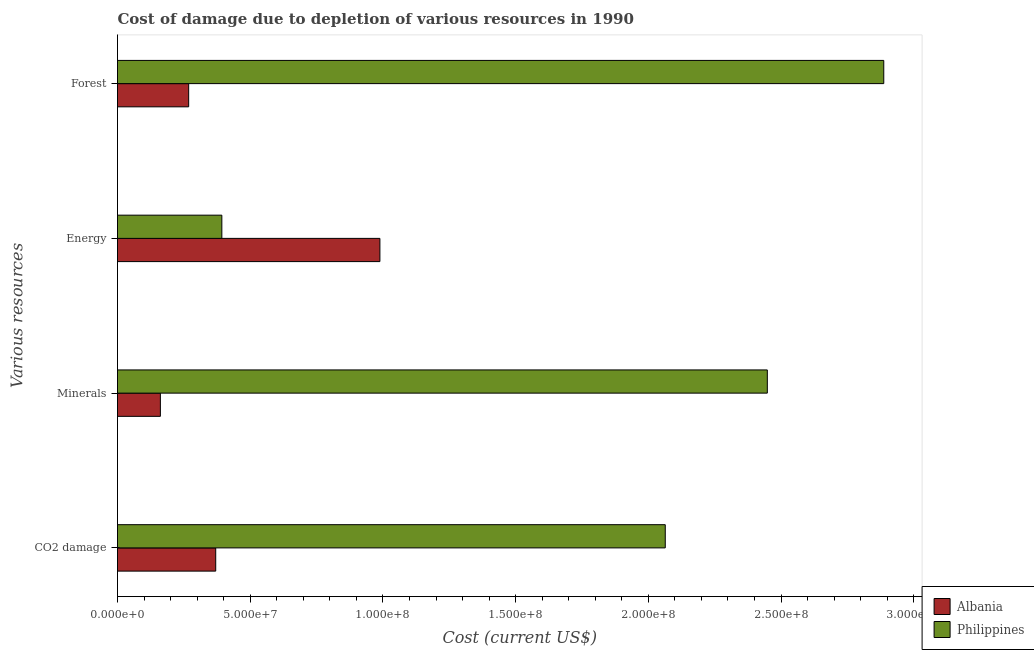Are the number of bars per tick equal to the number of legend labels?
Make the answer very short. Yes. Are the number of bars on each tick of the Y-axis equal?
Ensure brevity in your answer.  Yes. How many bars are there on the 2nd tick from the top?
Keep it short and to the point. 2. What is the label of the 4th group of bars from the top?
Your answer should be very brief. CO2 damage. What is the cost of damage due to depletion of coal in Philippines?
Offer a very short reply. 2.06e+08. Across all countries, what is the maximum cost of damage due to depletion of minerals?
Your answer should be very brief. 2.45e+08. Across all countries, what is the minimum cost of damage due to depletion of forests?
Ensure brevity in your answer.  2.68e+07. In which country was the cost of damage due to depletion of minerals maximum?
Your answer should be compact. Philippines. What is the total cost of damage due to depletion of coal in the graph?
Provide a short and direct response. 2.43e+08. What is the difference between the cost of damage due to depletion of forests in Albania and that in Philippines?
Keep it short and to the point. -2.62e+08. What is the difference between the cost of damage due to depletion of coal in Philippines and the cost of damage due to depletion of minerals in Albania?
Make the answer very short. 1.90e+08. What is the average cost of damage due to depletion of forests per country?
Your response must be concise. 1.58e+08. What is the difference between the cost of damage due to depletion of minerals and cost of damage due to depletion of energy in Albania?
Give a very brief answer. -8.27e+07. What is the ratio of the cost of damage due to depletion of minerals in Albania to that in Philippines?
Give a very brief answer. 0.07. Is the difference between the cost of damage due to depletion of coal in Albania and Philippines greater than the difference between the cost of damage due to depletion of minerals in Albania and Philippines?
Your answer should be very brief. Yes. What is the difference between the highest and the second highest cost of damage due to depletion of forests?
Provide a succinct answer. 2.62e+08. What is the difference between the highest and the lowest cost of damage due to depletion of energy?
Ensure brevity in your answer.  5.95e+07. Is the sum of the cost of damage due to depletion of energy in Philippines and Albania greater than the maximum cost of damage due to depletion of minerals across all countries?
Provide a short and direct response. No. What does the 2nd bar from the top in Forest represents?
Your answer should be compact. Albania. What does the 1st bar from the bottom in Energy represents?
Provide a succinct answer. Albania. Is it the case that in every country, the sum of the cost of damage due to depletion of coal and cost of damage due to depletion of minerals is greater than the cost of damage due to depletion of energy?
Provide a short and direct response. No. Are all the bars in the graph horizontal?
Make the answer very short. Yes. How many countries are there in the graph?
Your answer should be very brief. 2. Does the graph contain any zero values?
Offer a very short reply. No. How are the legend labels stacked?
Give a very brief answer. Vertical. What is the title of the graph?
Provide a succinct answer. Cost of damage due to depletion of various resources in 1990 . What is the label or title of the X-axis?
Your answer should be compact. Cost (current US$). What is the label or title of the Y-axis?
Ensure brevity in your answer.  Various resources. What is the Cost (current US$) of Albania in CO2 damage?
Offer a very short reply. 3.70e+07. What is the Cost (current US$) of Philippines in CO2 damage?
Offer a very short reply. 2.06e+08. What is the Cost (current US$) of Albania in Minerals?
Your response must be concise. 1.62e+07. What is the Cost (current US$) in Philippines in Minerals?
Ensure brevity in your answer.  2.45e+08. What is the Cost (current US$) in Albania in Energy?
Offer a very short reply. 9.89e+07. What is the Cost (current US$) of Philippines in Energy?
Give a very brief answer. 3.93e+07. What is the Cost (current US$) of Albania in Forest?
Your answer should be very brief. 2.68e+07. What is the Cost (current US$) in Philippines in Forest?
Ensure brevity in your answer.  2.89e+08. Across all Various resources, what is the maximum Cost (current US$) in Albania?
Make the answer very short. 9.89e+07. Across all Various resources, what is the maximum Cost (current US$) in Philippines?
Keep it short and to the point. 2.89e+08. Across all Various resources, what is the minimum Cost (current US$) in Albania?
Provide a succinct answer. 1.62e+07. Across all Various resources, what is the minimum Cost (current US$) in Philippines?
Ensure brevity in your answer.  3.93e+07. What is the total Cost (current US$) in Albania in the graph?
Provide a short and direct response. 1.79e+08. What is the total Cost (current US$) in Philippines in the graph?
Your answer should be compact. 7.79e+08. What is the difference between the Cost (current US$) in Albania in CO2 damage and that in Minerals?
Make the answer very short. 2.08e+07. What is the difference between the Cost (current US$) in Philippines in CO2 damage and that in Minerals?
Make the answer very short. -3.85e+07. What is the difference between the Cost (current US$) in Albania in CO2 damage and that in Energy?
Provide a succinct answer. -6.19e+07. What is the difference between the Cost (current US$) of Philippines in CO2 damage and that in Energy?
Your response must be concise. 1.67e+08. What is the difference between the Cost (current US$) in Albania in CO2 damage and that in Forest?
Offer a very short reply. 1.02e+07. What is the difference between the Cost (current US$) of Philippines in CO2 damage and that in Forest?
Make the answer very short. -8.23e+07. What is the difference between the Cost (current US$) of Albania in Minerals and that in Energy?
Your answer should be compact. -8.27e+07. What is the difference between the Cost (current US$) of Philippines in Minerals and that in Energy?
Ensure brevity in your answer.  2.06e+08. What is the difference between the Cost (current US$) of Albania in Minerals and that in Forest?
Offer a terse response. -1.07e+07. What is the difference between the Cost (current US$) of Philippines in Minerals and that in Forest?
Make the answer very short. -4.39e+07. What is the difference between the Cost (current US$) of Albania in Energy and that in Forest?
Offer a very short reply. 7.20e+07. What is the difference between the Cost (current US$) in Philippines in Energy and that in Forest?
Give a very brief answer. -2.49e+08. What is the difference between the Cost (current US$) in Albania in CO2 damage and the Cost (current US$) in Philippines in Minerals?
Provide a short and direct response. -2.08e+08. What is the difference between the Cost (current US$) of Albania in CO2 damage and the Cost (current US$) of Philippines in Energy?
Your response must be concise. -2.31e+06. What is the difference between the Cost (current US$) in Albania in CO2 damage and the Cost (current US$) in Philippines in Forest?
Provide a succinct answer. -2.52e+08. What is the difference between the Cost (current US$) of Albania in Minerals and the Cost (current US$) of Philippines in Energy?
Make the answer very short. -2.32e+07. What is the difference between the Cost (current US$) in Albania in Minerals and the Cost (current US$) in Philippines in Forest?
Your answer should be compact. -2.73e+08. What is the difference between the Cost (current US$) in Albania in Energy and the Cost (current US$) in Philippines in Forest?
Your answer should be compact. -1.90e+08. What is the average Cost (current US$) in Albania per Various resources?
Your answer should be very brief. 4.47e+07. What is the average Cost (current US$) of Philippines per Various resources?
Your answer should be compact. 1.95e+08. What is the difference between the Cost (current US$) of Albania and Cost (current US$) of Philippines in CO2 damage?
Provide a succinct answer. -1.69e+08. What is the difference between the Cost (current US$) in Albania and Cost (current US$) in Philippines in Minerals?
Your answer should be very brief. -2.29e+08. What is the difference between the Cost (current US$) of Albania and Cost (current US$) of Philippines in Energy?
Your answer should be compact. 5.95e+07. What is the difference between the Cost (current US$) in Albania and Cost (current US$) in Philippines in Forest?
Make the answer very short. -2.62e+08. What is the ratio of the Cost (current US$) in Albania in CO2 damage to that in Minerals?
Offer a very short reply. 2.29. What is the ratio of the Cost (current US$) of Philippines in CO2 damage to that in Minerals?
Provide a succinct answer. 0.84. What is the ratio of the Cost (current US$) in Albania in CO2 damage to that in Energy?
Give a very brief answer. 0.37. What is the ratio of the Cost (current US$) of Philippines in CO2 damage to that in Energy?
Provide a short and direct response. 5.25. What is the ratio of the Cost (current US$) of Albania in CO2 damage to that in Forest?
Your response must be concise. 1.38. What is the ratio of the Cost (current US$) of Philippines in CO2 damage to that in Forest?
Provide a short and direct response. 0.71. What is the ratio of the Cost (current US$) of Albania in Minerals to that in Energy?
Offer a very short reply. 0.16. What is the ratio of the Cost (current US$) in Philippines in Minerals to that in Energy?
Provide a succinct answer. 6.23. What is the ratio of the Cost (current US$) in Albania in Minerals to that in Forest?
Your answer should be compact. 0.6. What is the ratio of the Cost (current US$) in Philippines in Minerals to that in Forest?
Ensure brevity in your answer.  0.85. What is the ratio of the Cost (current US$) in Albania in Energy to that in Forest?
Your answer should be very brief. 3.69. What is the ratio of the Cost (current US$) in Philippines in Energy to that in Forest?
Ensure brevity in your answer.  0.14. What is the difference between the highest and the second highest Cost (current US$) of Albania?
Your response must be concise. 6.19e+07. What is the difference between the highest and the second highest Cost (current US$) of Philippines?
Make the answer very short. 4.39e+07. What is the difference between the highest and the lowest Cost (current US$) of Albania?
Offer a terse response. 8.27e+07. What is the difference between the highest and the lowest Cost (current US$) in Philippines?
Give a very brief answer. 2.49e+08. 